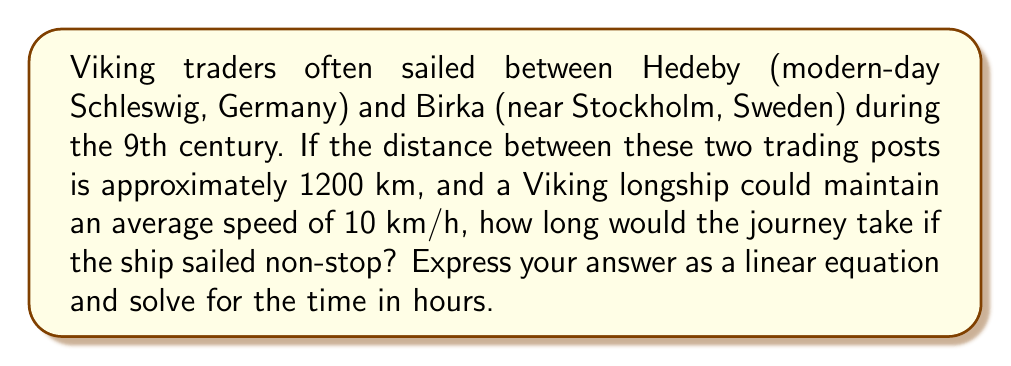Help me with this question. Let's approach this step-by-step:

1) First, we need to identify the variables:
   Let $t$ = time in hours
   Let $d$ = distance in kilometers
   Let $r$ = rate (speed) in km/h

2) We know that:
   $d = 1200$ km
   $r = 10$ km/h

3) We can use the distance formula:
   $d = r \cdot t$

4) Substituting our known values:
   $1200 = 10t$

5) This is our linear equation. To solve for $t$, we divide both sides by 10:
   $\frac{1200}{10} = \frac{10t}{10}$

6) Simplifying:
   $120 = t$

Therefore, the journey would take 120 hours if sailing non-stop.
Answer: $t = 120$ hours 